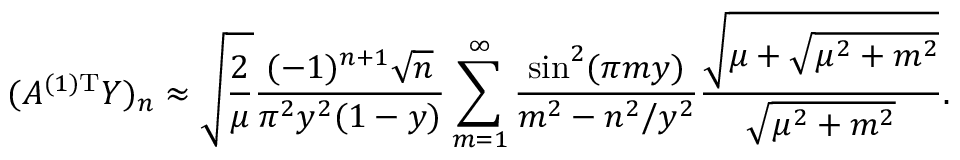Convert formula to latex. <formula><loc_0><loc_0><loc_500><loc_500>( A ^ { ( 1 ) T } Y ) _ { n } \approx \sqrt { \frac { 2 } { \mu } } \frac { ( - 1 ) ^ { n + 1 } \sqrt { n } } { \pi ^ { 2 } y ^ { 2 } ( 1 - y ) } \sum _ { m = 1 } ^ { \infty } \frac { \sin ^ { 2 } ( \pi m y ) } { m ^ { 2 } - n ^ { 2 } / y ^ { 2 } } \frac { \sqrt { \mu + \sqrt { \mu ^ { 2 } + m ^ { 2 } } } } { \sqrt { \mu ^ { 2 } + m ^ { 2 } } } .</formula> 